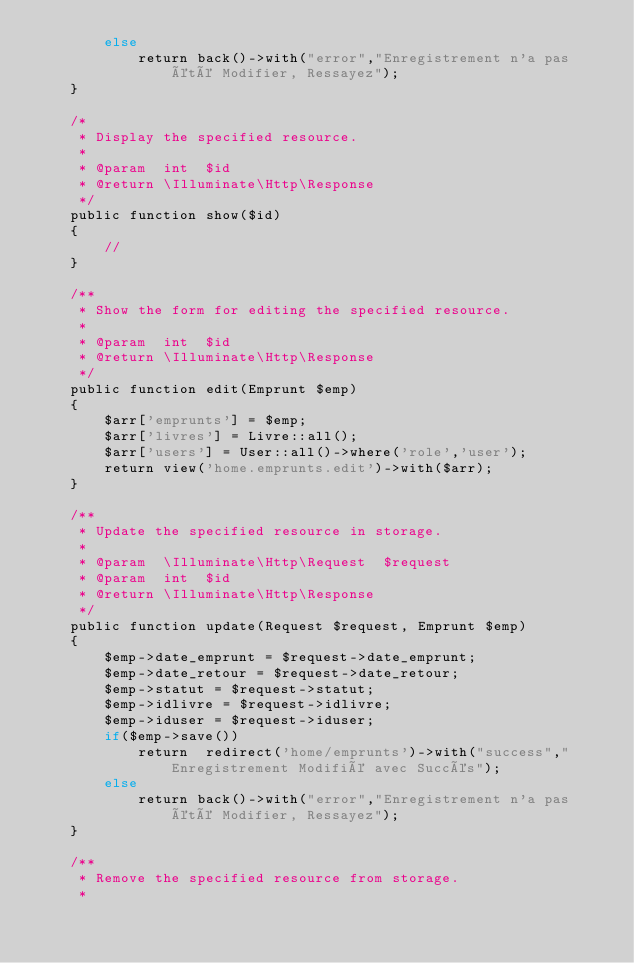<code> <loc_0><loc_0><loc_500><loc_500><_PHP_>        else
            return back()->with("error","Enregistrement n'a pas été Modifier, Ressayez");
    } 

    /*
     * Display the specified resource.
     *
     * @param  int  $id
     * @return \Illuminate\Http\Response
     */
    public function show($id)
    {
        //
    }

    /**
     * Show the form for editing the specified resource.
     *
     * @param  int  $id
     * @return \Illuminate\Http\Response
     */
    public function edit(Emprunt $emp)
    {
        $arr['emprunts'] = $emp;
        $arr['livres'] = Livre::all();
        $arr['users'] = User::all()->where('role','user');
        return view('home.emprunts.edit')->with($arr);
    }

    /**
     * Update the specified resource in storage.
     *
     * @param  \Illuminate\Http\Request  $request
     * @param  int  $id
     * @return \Illuminate\Http\Response
     */
    public function update(Request $request, Emprunt $emp)
    {
        $emp->date_emprunt = $request->date_emprunt;
        $emp->date_retour = $request->date_retour;
        $emp->statut = $request->statut;
        $emp->idlivre = $request->idlivre;
        $emp->iduser = $request->iduser;
        if($emp->save())
            return  redirect('home/emprunts')->with("success","Enregistrement Modifié avec Succés");
        else
            return back()->with("error","Enregistrement n'a pas été Modifier, Ressayez");
    }

    /**
     * Remove the specified resource from storage.
     *</code> 